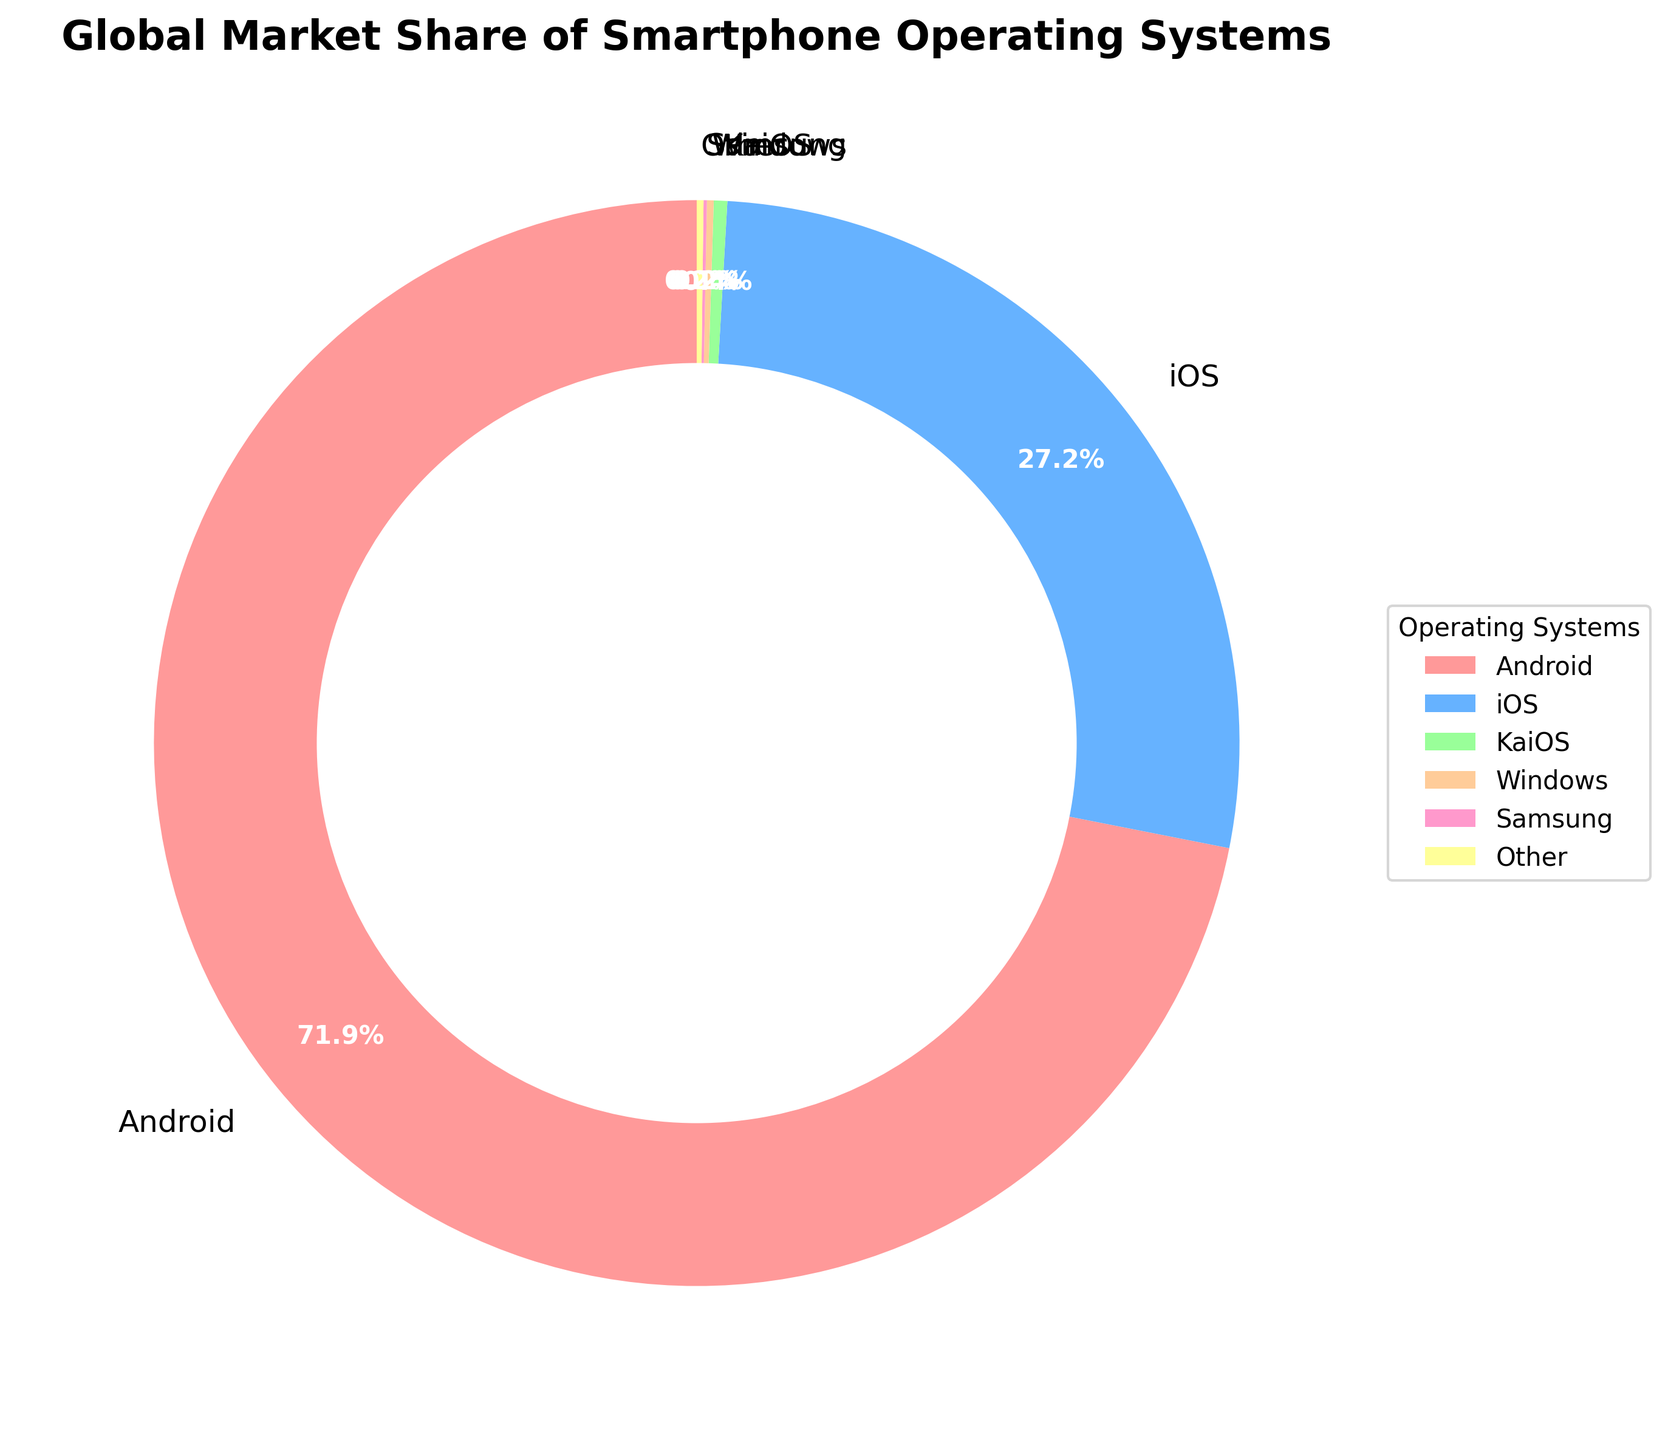What is the market share of Android? According to the figure, the market share of Android is explicitly labeled in the pie chart.
Answer: 71.9% Which operating system has the smallest market share? The smallest portion of the pie chart represents the operating system with the smallest market share. This is clearly labeled as Samsung.
Answer: Samsung What is the combined market share of iOS and Android? The market share of iOS is 27.2% and Android is 71.9%. Adding these together gives 27.2 + 71.9 = 99.1%.
Answer: 99.1% Which operating system has a greater market share, KaiOS or Windows? By comparing the labeled percentages directly on the pie chart, KaiOS has a market share of 0.4% and Windows has 0.2%.
Answer: KaiOS What is the difference in market share between the largest and smallest operating systems? The largest operating system is Android at 71.9%, and the smallest is Samsung at 0.1%. The difference is 71.9 - 0.1 = 71.8%.
Answer: 71.8% Which operating system is represented by the green color in the pie chart? According to the pie chart, the green color corresponds to KaiOS.
Answer: KaiOS Compare the market share of iOS and all smaller operating systems combined (KaiOS, Windows, Samsung, Other). Which is larger? First, sum the market shares of the smaller operating systems: 0.4 + 0.2 + 0.1 + 0.2 = 0.9%. iOS has a market share of 27.2%, which is significantly larger than 0.9%.
Answer: iOS 